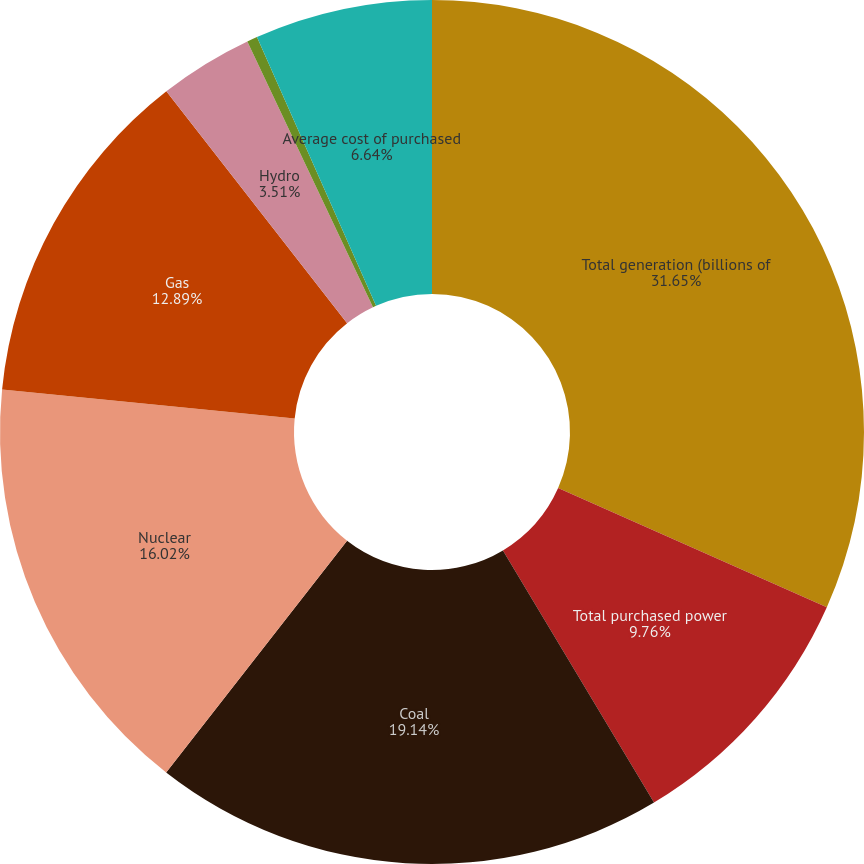Convert chart to OTSL. <chart><loc_0><loc_0><loc_500><loc_500><pie_chart><fcel>Total generation (billions of<fcel>Total purchased power<fcel>Coal<fcel>Nuclear<fcel>Gas<fcel>Hydro<fcel>Average cost of fuel generated<fcel>Average cost of purchased<nl><fcel>31.65%<fcel>9.76%<fcel>19.14%<fcel>16.02%<fcel>12.89%<fcel>3.51%<fcel>0.39%<fcel>6.64%<nl></chart> 